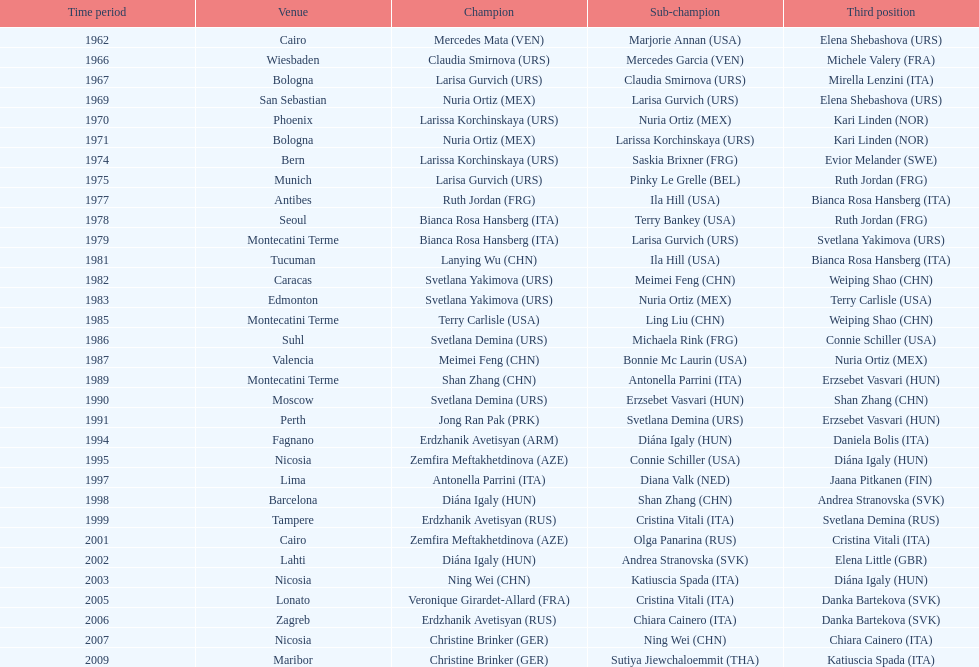Who won the only gold medal in 1962? Mercedes Mata. 